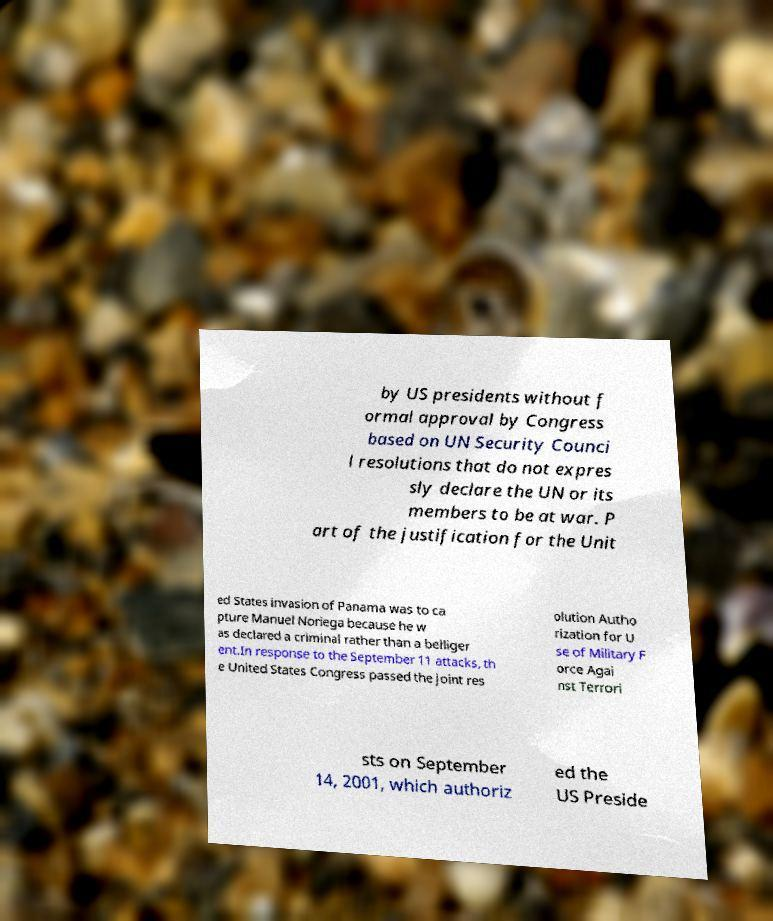Can you accurately transcribe the text from the provided image for me? by US presidents without f ormal approval by Congress based on UN Security Counci l resolutions that do not expres sly declare the UN or its members to be at war. P art of the justification for the Unit ed States invasion of Panama was to ca pture Manuel Noriega because he w as declared a criminal rather than a belliger ent.In response to the September 11 attacks, th e United States Congress passed the joint res olution Autho rization for U se of Military F orce Agai nst Terrori sts on September 14, 2001, which authoriz ed the US Preside 